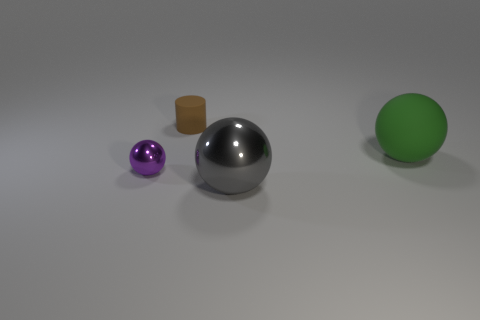How does the surface texture of the green ball compare to the purple ball? While both the green and purple balls display smooth surfaces, the green ball has a matte finish that scatters light, giving it a non-reflective appearance, whereas the purple ball has a shiny finish that reflects light, giving it a glossy look. 